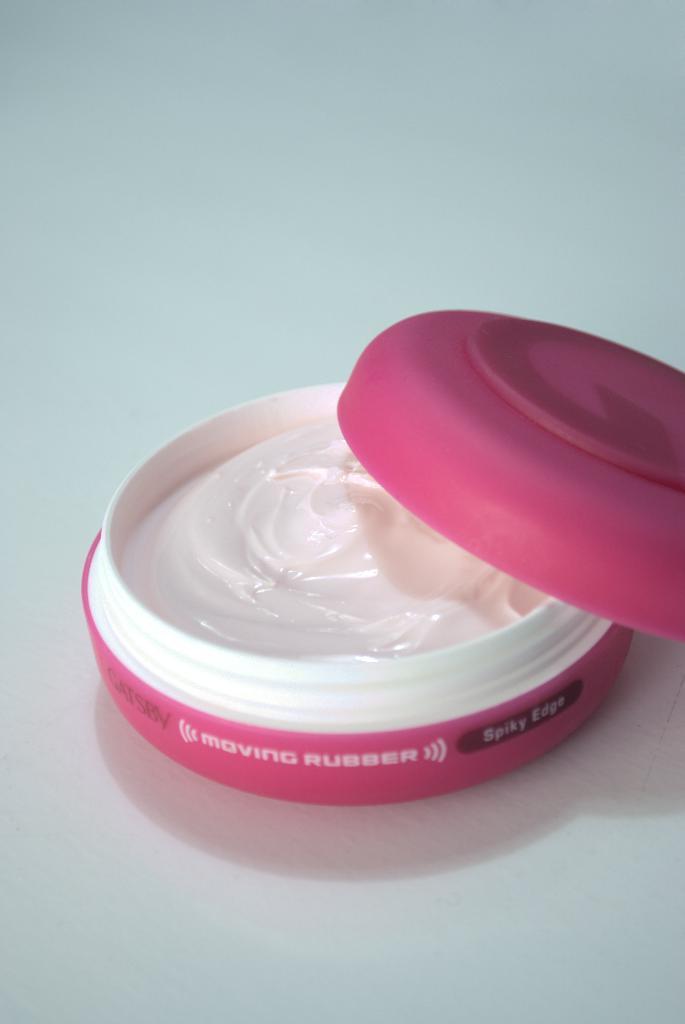How would you summarize this image in a sentence or two? There is white color cream in a box which is opened on the white color floor. On the right side, there is a pink color cap which is partially on this box on the floor. And the background is white in color. 